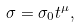<formula> <loc_0><loc_0><loc_500><loc_500>\sigma = \sigma _ { 0 } t ^ { \mu } ,</formula> 